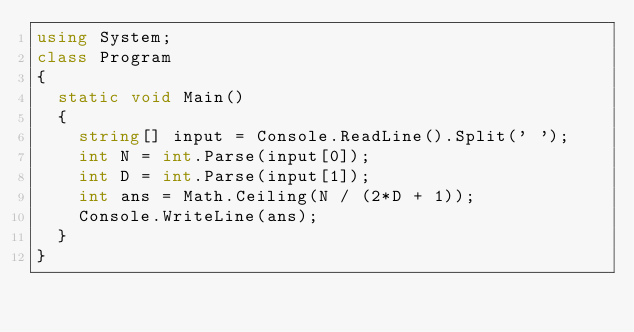<code> <loc_0><loc_0><loc_500><loc_500><_C#_>using System;
class Program
{
  static void Main()
  {
    string[] input = Console.ReadLine().Split(' ');
    int N = int.Parse(input[0]);
    int D = int.Parse(input[1]);
    int ans = Math.Ceiling(N / (2*D + 1));
    Console.WriteLine(ans);
  }
}</code> 